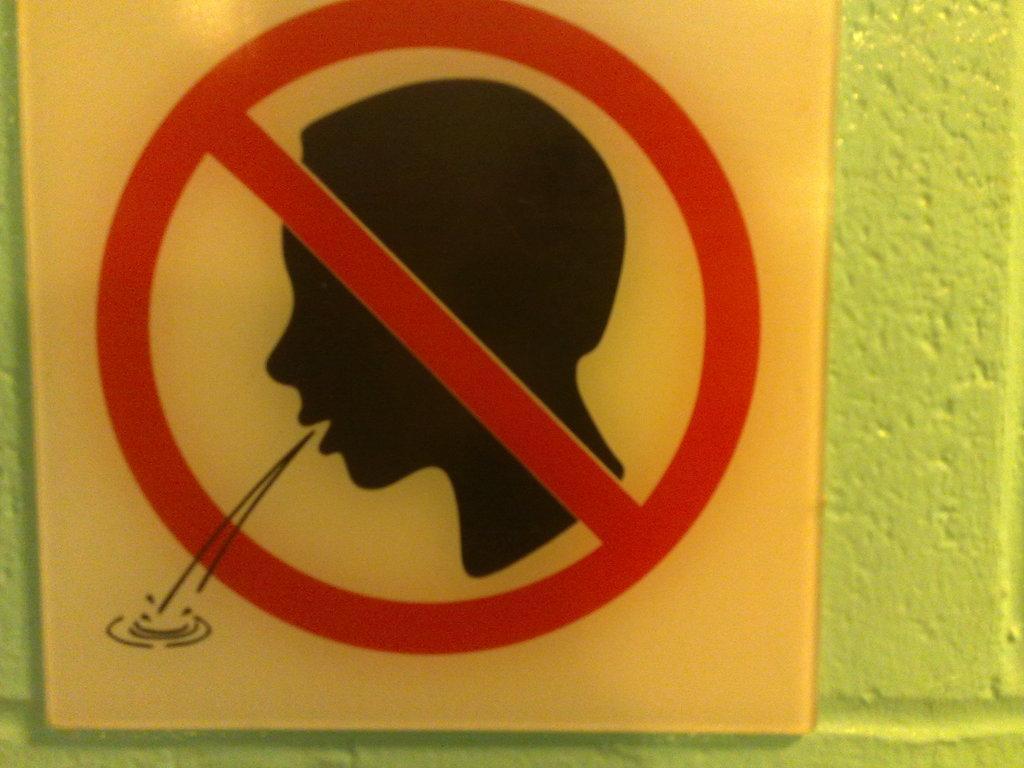Can you describe this image briefly? We can see a board. In the background it is green. 